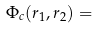<formula> <loc_0><loc_0><loc_500><loc_500>\Phi _ { c } ( { r } _ { 1 } , { r } _ { 2 } ) =</formula> 